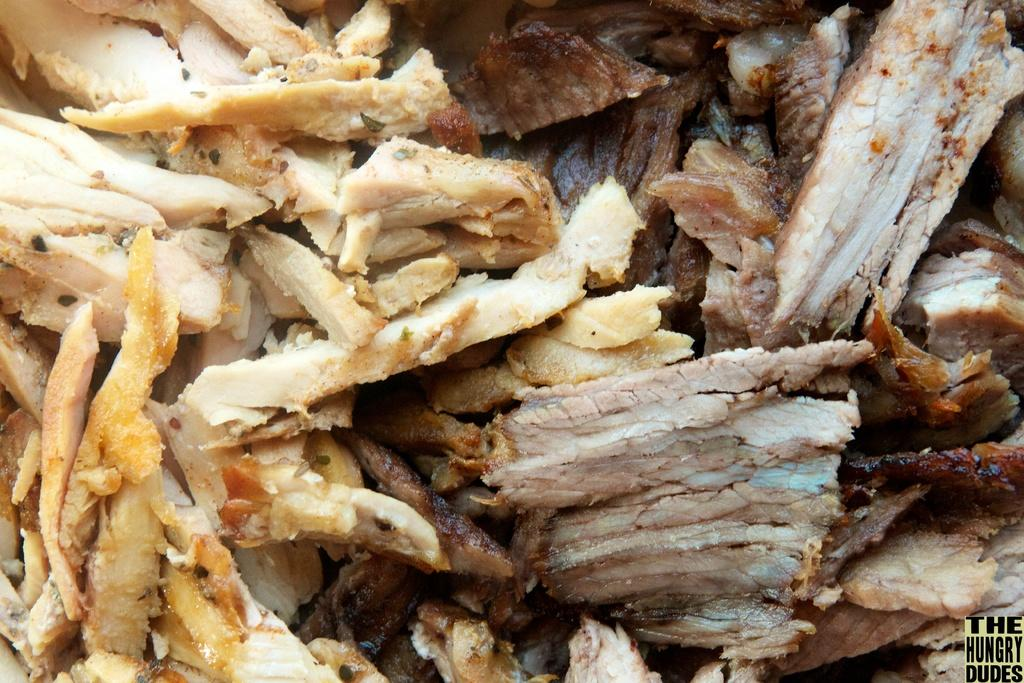What can be seen in the image? There is food visible in the image. What type of drum is being played in the image? There is no drum present in the image; it only features food. 